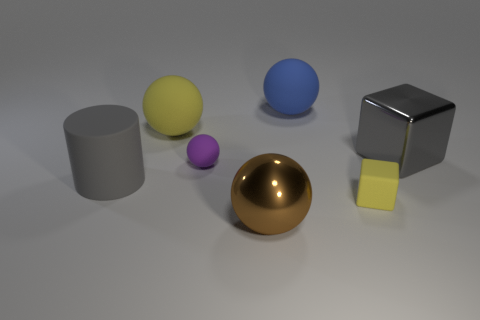There is a large gray thing that is on the right side of the yellow thing that is behind the yellow cube; what is its shape?
Offer a very short reply. Cube. There is a small thing to the left of the big brown metallic ball; is its shape the same as the large gray metal thing?
Ensure brevity in your answer.  No. What number of things are either big balls that are in front of the yellow matte block or matte things that are left of the blue object?
Your response must be concise. 4. What color is the cylinder left of the metallic object that is to the left of the small yellow matte block?
Keep it short and to the point. Gray. There is a small block that is the same material as the big cylinder; what is its color?
Your response must be concise. Yellow. How many things have the same color as the tiny ball?
Your response must be concise. 0. How many objects are either big red shiny things or big cubes?
Make the answer very short. 1. What shape is the yellow rubber thing that is the same size as the blue rubber ball?
Make the answer very short. Sphere. How many objects are to the right of the big brown shiny sphere and behind the gray metallic thing?
Your answer should be compact. 1. What is the big sphere that is left of the purple rubber sphere made of?
Make the answer very short. Rubber. 